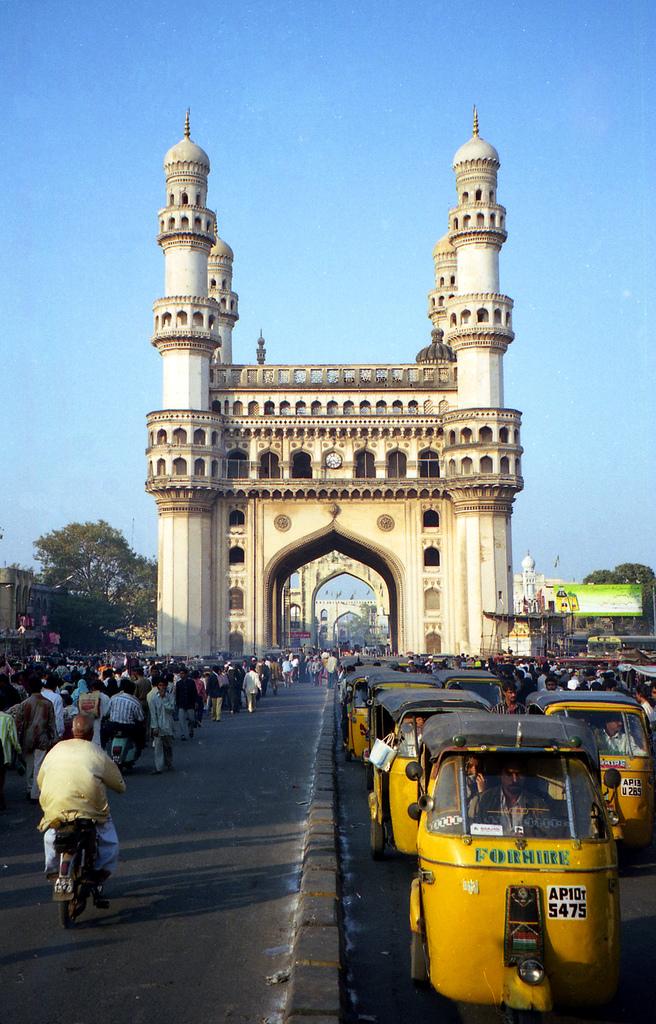What identification number is on the closest taxi?
Offer a terse response. 5475. What do the taxis say in green text?
Offer a very short reply. For hire. 